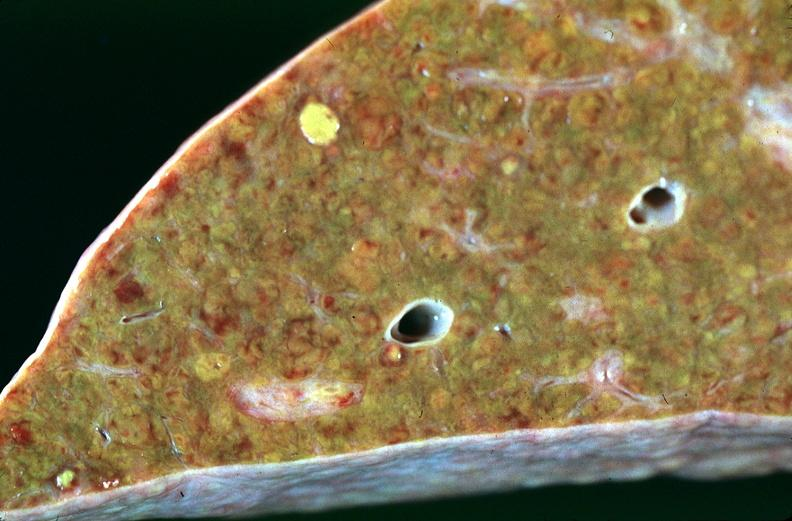s that present?
Answer the question using a single word or phrase. No 